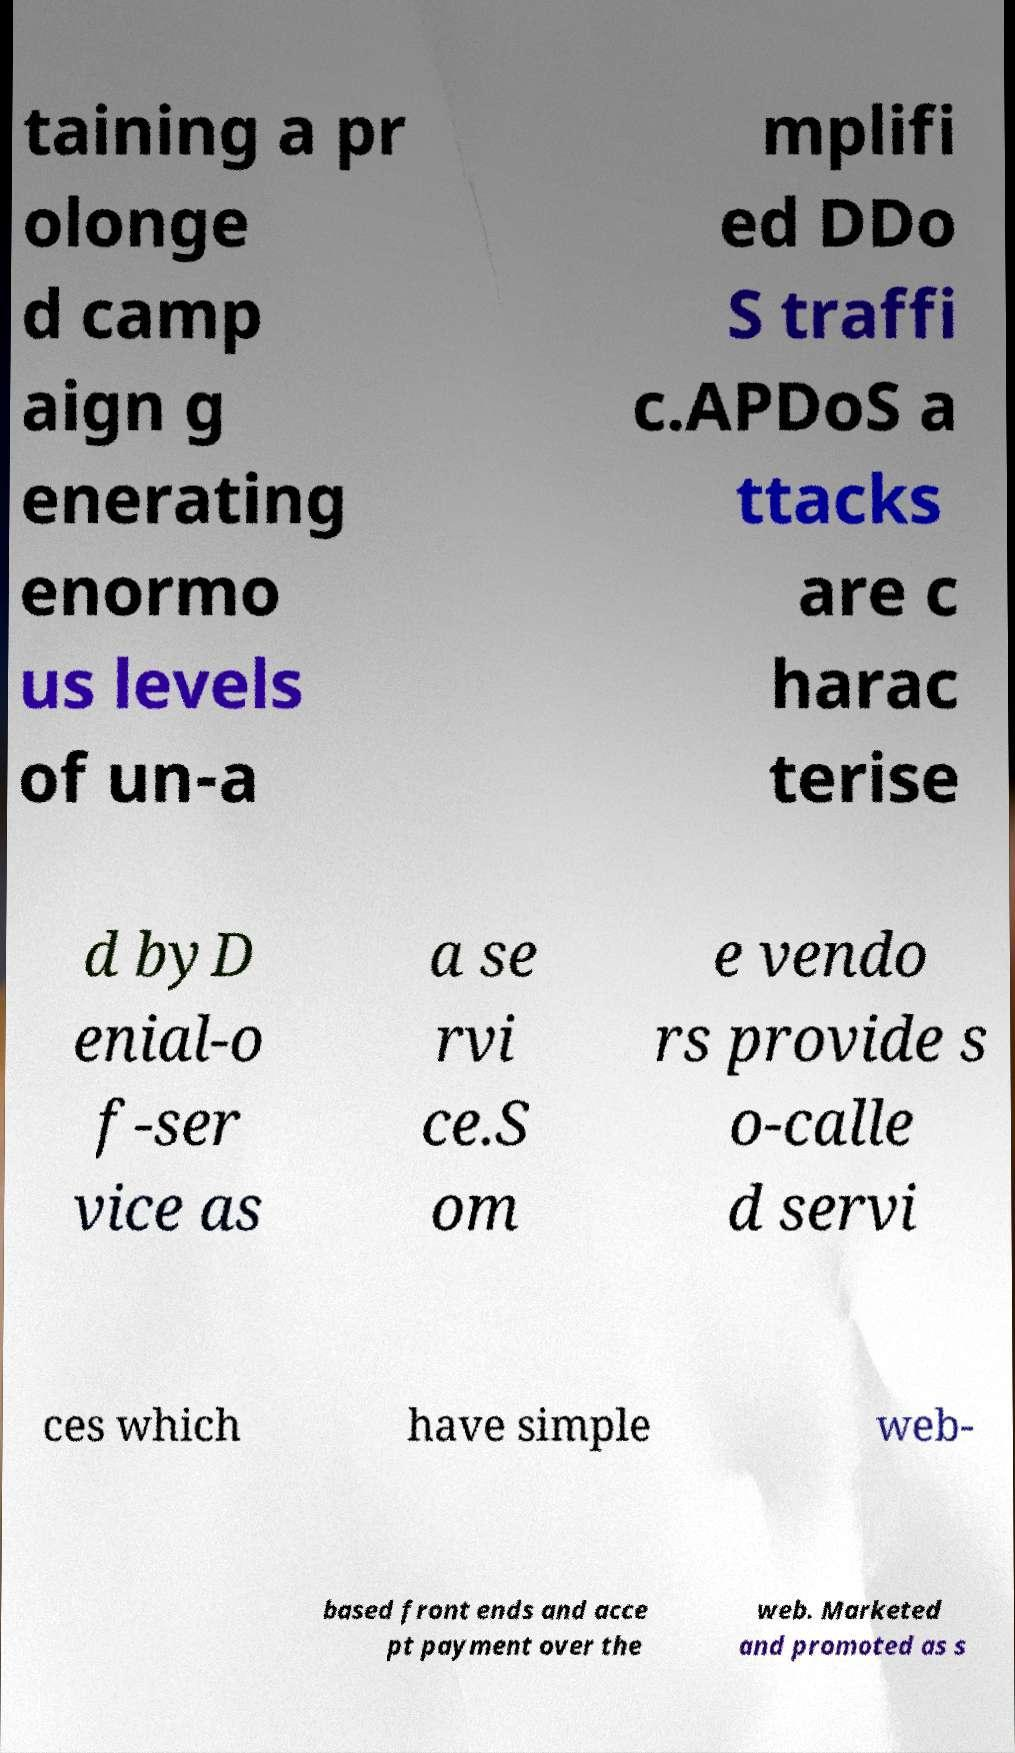Can you accurately transcribe the text from the provided image for me? taining a pr olonge d camp aign g enerating enormo us levels of un-a mplifi ed DDo S traffi c.APDoS a ttacks are c harac terise d byD enial-o f-ser vice as a se rvi ce.S om e vendo rs provide s o-calle d servi ces which have simple web- based front ends and acce pt payment over the web. Marketed and promoted as s 